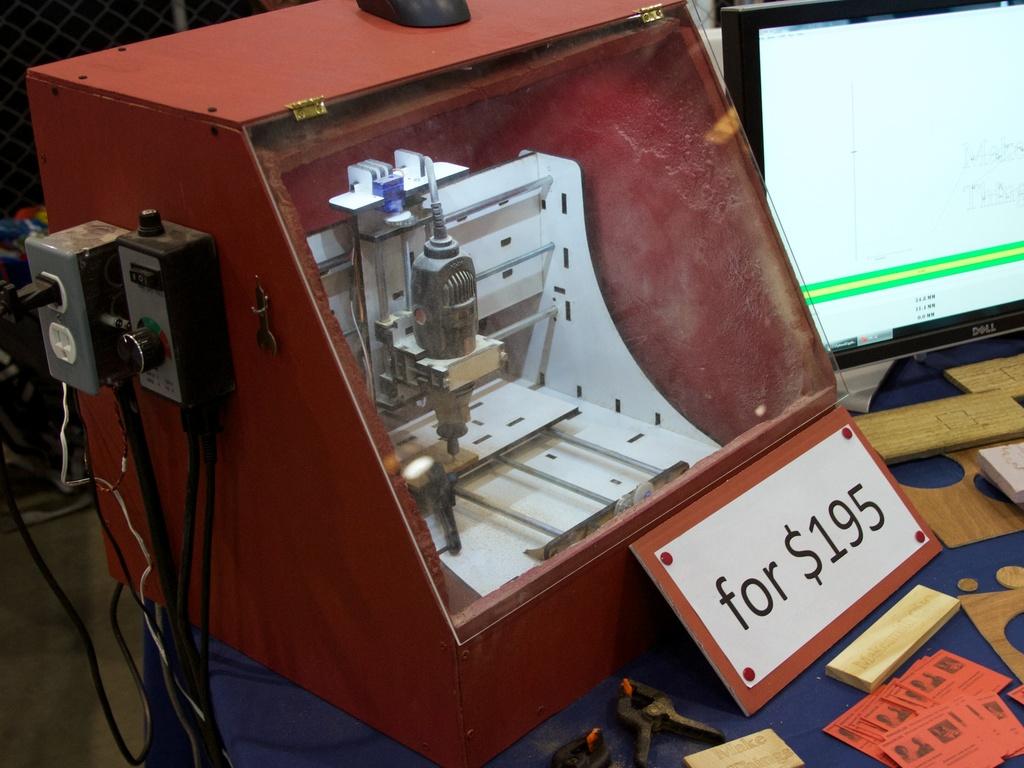What is the price of that item?
Your answer should be compact. $195. Is this machine sold for less than $200?
Offer a very short reply. Yes. 